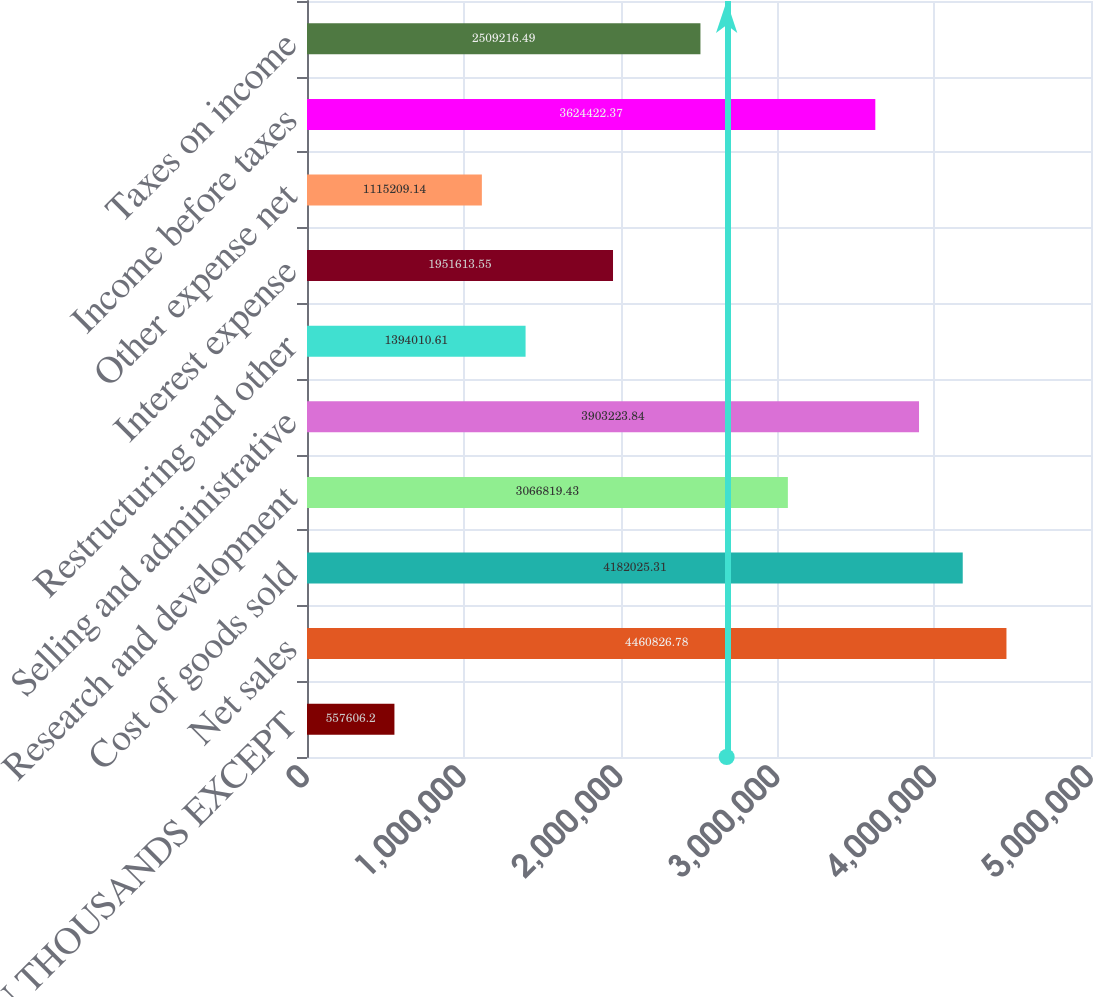Convert chart. <chart><loc_0><loc_0><loc_500><loc_500><bar_chart><fcel>(DOLLARS IN THOUSANDS EXCEPT<fcel>Net sales<fcel>Cost of goods sold<fcel>Research and development<fcel>Selling and administrative<fcel>Restructuring and other<fcel>Interest expense<fcel>Other expense net<fcel>Income before taxes<fcel>Taxes on income<nl><fcel>557606<fcel>4.46083e+06<fcel>4.18203e+06<fcel>3.06682e+06<fcel>3.90322e+06<fcel>1.39401e+06<fcel>1.95161e+06<fcel>1.11521e+06<fcel>3.62442e+06<fcel>2.50922e+06<nl></chart> 